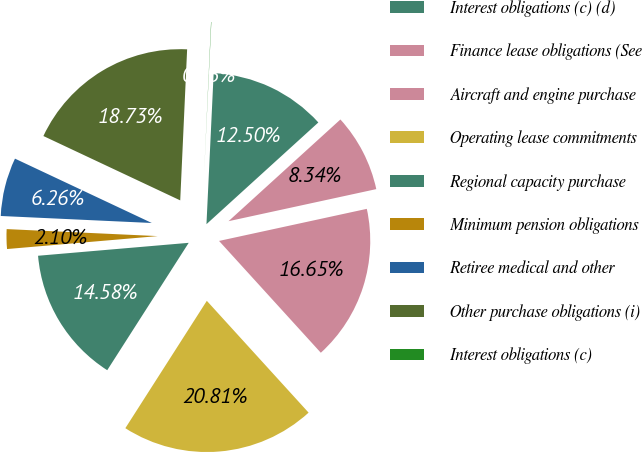Convert chart to OTSL. <chart><loc_0><loc_0><loc_500><loc_500><pie_chart><fcel>Interest obligations (c) (d)<fcel>Finance lease obligations (See<fcel>Aircraft and engine purchase<fcel>Operating lease commitments<fcel>Regional capacity purchase<fcel>Minimum pension obligations<fcel>Retiree medical and other<fcel>Other purchase obligations (i)<fcel>Interest obligations (c)<nl><fcel>12.5%<fcel>8.34%<fcel>16.65%<fcel>20.81%<fcel>14.58%<fcel>2.1%<fcel>6.26%<fcel>18.73%<fcel>0.03%<nl></chart> 